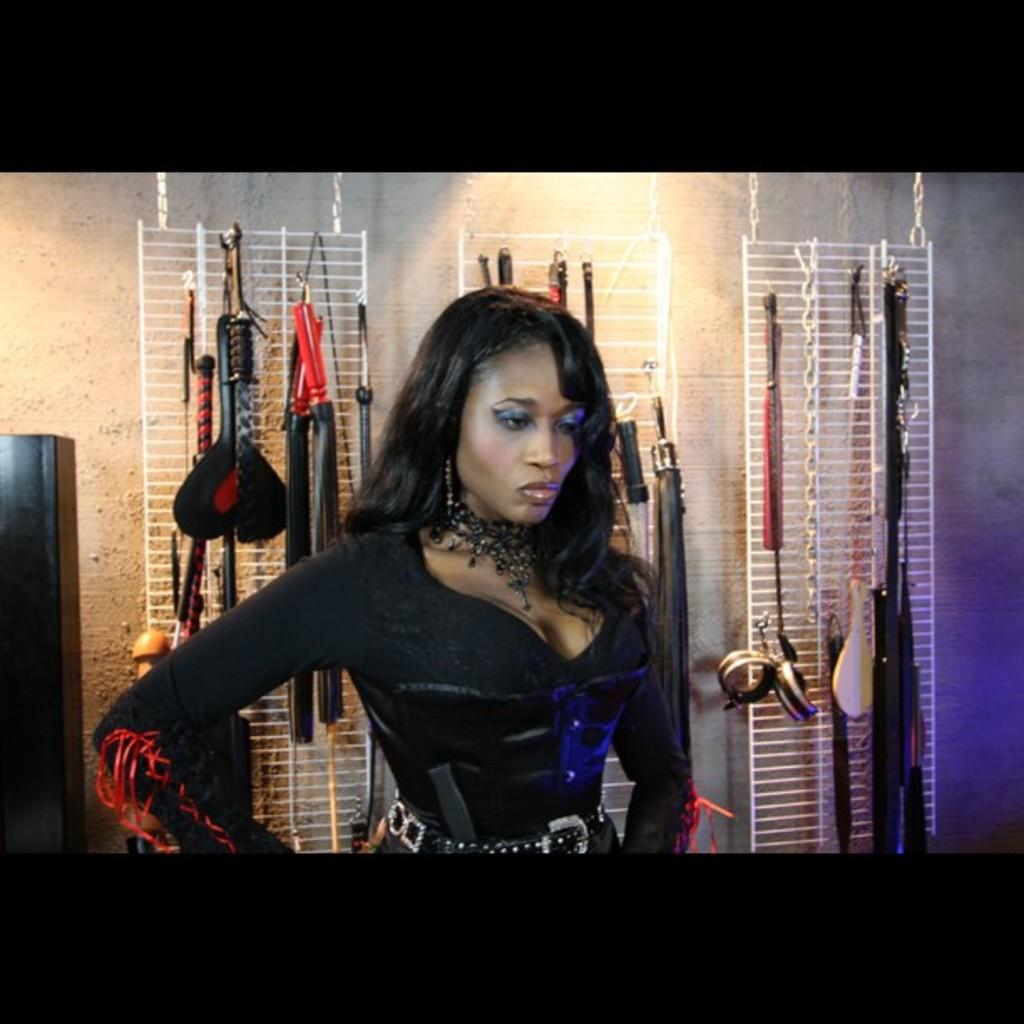Who is present in the image? There is a woman in the image. What can be seen behind the woman? There are objects hanging behind the woman. What is visible in the background of the image? There is a wall visible in the background of the image. What type of whistle can be heard in the image? There is no whistle present in the image. 